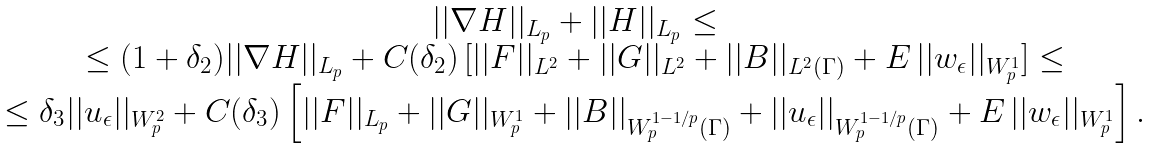Convert formula to latex. <formula><loc_0><loc_0><loc_500><loc_500>\begin{array} { c } | | \nabla H | | _ { L _ { p } } + | | H | | _ { L _ { p } } \leq \\ \leq ( 1 + \delta _ { 2 } ) | | \nabla H | | _ { L _ { p } } + C ( \delta _ { 2 } ) \, [ | | F | | _ { L ^ { 2 } } + | | G | | _ { L ^ { 2 } } + | | B | | _ { L ^ { 2 } ( \Gamma ) } + E \, | | w _ { \epsilon } | | _ { W ^ { 1 } _ { p } } ] \leq \\ \leq \delta _ { 3 } | | u _ { \epsilon } | | _ { W ^ { 2 } _ { p } } + C ( \delta _ { 3 } ) \left [ | | F | | _ { L _ { p } } + | | G | | _ { W ^ { 1 } _ { p } } + | | B | | _ { W ^ { 1 - 1 / p } _ { p } ( \Gamma ) } + | | u _ { \epsilon } | | _ { W ^ { 1 - 1 / p } _ { p } ( \Gamma ) } + E \, | | w _ { \epsilon } | | _ { W ^ { 1 } _ { p } } \right ] . \end{array}</formula> 